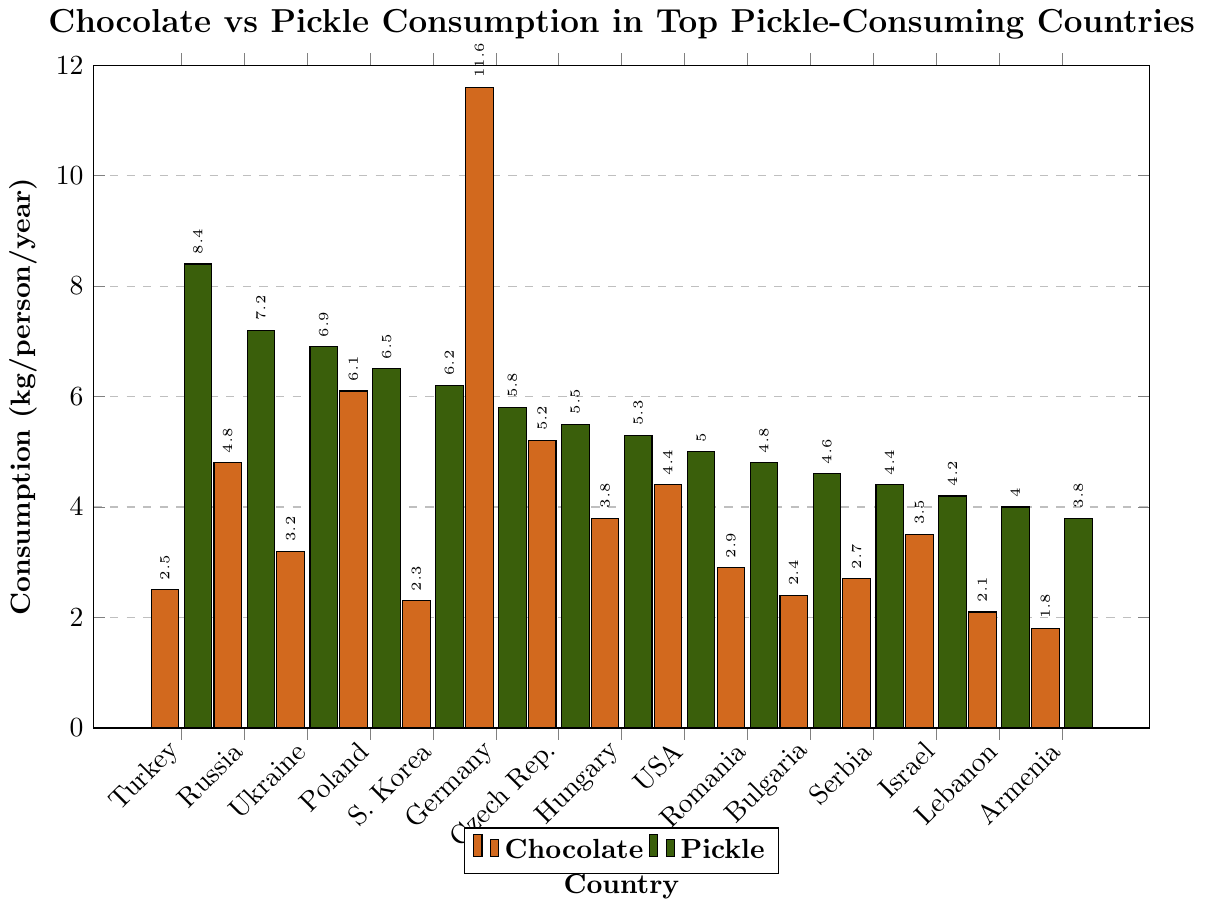Which country has the highest chocolate consumption per capita? By visually inspecting the heights of the chocolate bars, we see that Germany has the tallest bar. Therefore, Germany has the highest chocolate consumption per capita.
Answer: Germany Which country has the highest pickle consumption per capita? By visually inspecting the heights of the pickle bars, we see that Turkey has the tallest bar. Therefore, Turkey has the highest pickle consumption per capita.
Answer: Turkey What is the difference between chocolate and pickle consumption in Poland? First, identify the bars for Poland: chocolate is 6.1 kg/person/year and pickle is 6.5 kg/person/year. Subtract 6.1 from 6.5.
Answer: 0.4 kg/person/year Which country has the lowest chocolate consumption per capita? By visually inspecting the heights of the chocolate bars, we see that Armenia has the shortest bar. Therefore, Armenia has the lowest chocolate consumption per capita.
Answer: Armenia What is the total chocolate consumption for Turkey, Russia, and Ukraine combined? First, identify the chocolate consumption for Turkey (2.5 kg), Russia (4.8 kg), and Ukraine (3.2 kg). Sum these values: 2.5 + 4.8 + 3.2 = 10.5 kg/person/year.
Answer: 10.5 kg/person/year Which country has a higher chocolate consumption: South Korea or Israel? By visually inspecting the height of the chocolate bars for South Korea and Israel, we see that Israel's bar (3.5 kg/person/year) is taller than South Korea's (2.3 kg/person/year).
Answer: Israel What is the average pickle consumption among Germany, Czech Republic, and Hungary? Identify pickle consumption for Germany (5.8 kg), Czech Republic (5.5 kg), and Hungary (5.3 kg). Sum these values and divide by 3: (5.8 + 5.5 + 5.3) / 3 = 16.6 / 3 ≈ 5.53 kg/person/year.
Answer: 5.53 kg/person/year Which countries have higher pickle than chocolate consumption per capita? Visually compare the heights of the chocolate and pickle bars for each country. Those countries are Turkey, Russia, Ukraine, South Korea, Romania, Bulgaria, Serbia, Israel, Lebanon, and Armenia.
Answer: Turkey, Russia, Ukraine, South Korea, Romania, Bulgaria, Serbia, Israel, Lebanon, Armenia 